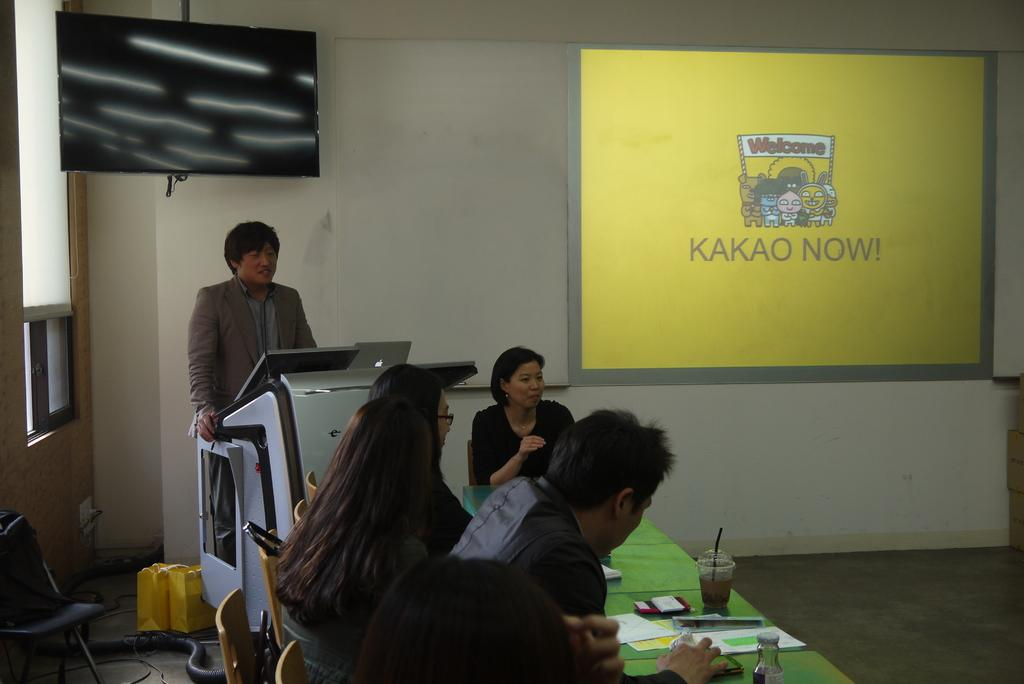<image>
Share a concise interpretation of the image provided. A man is speaking in a classroom with a slide on the projector screen that says Kakao Now. 